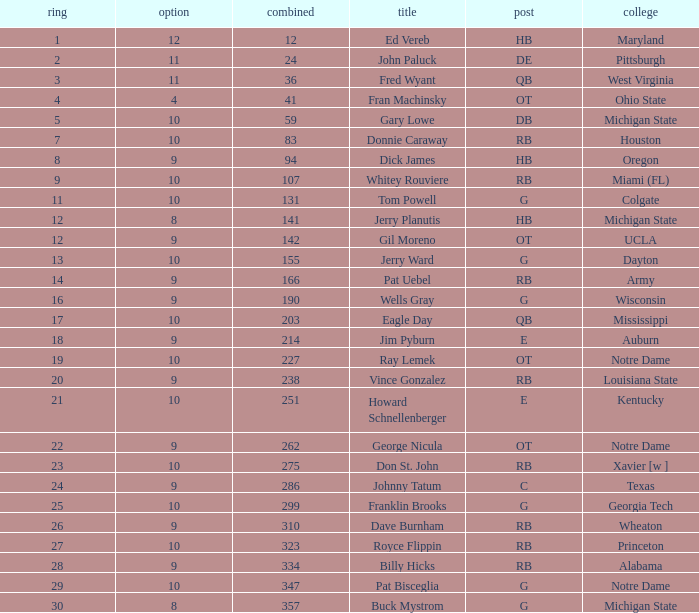What is the highest round number for donnie caraway? 7.0. 